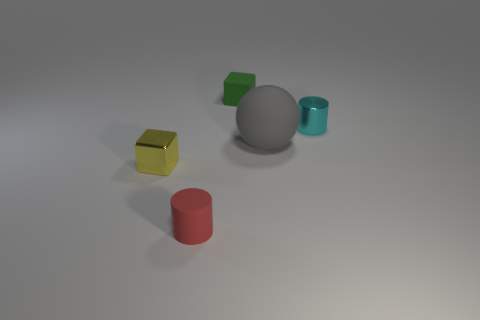What colors are the cubes in the image? The cubes in the image are yellow and green. Which cube is closer to the red cylinder? The yellow cube is closer to the small red cylinder. 